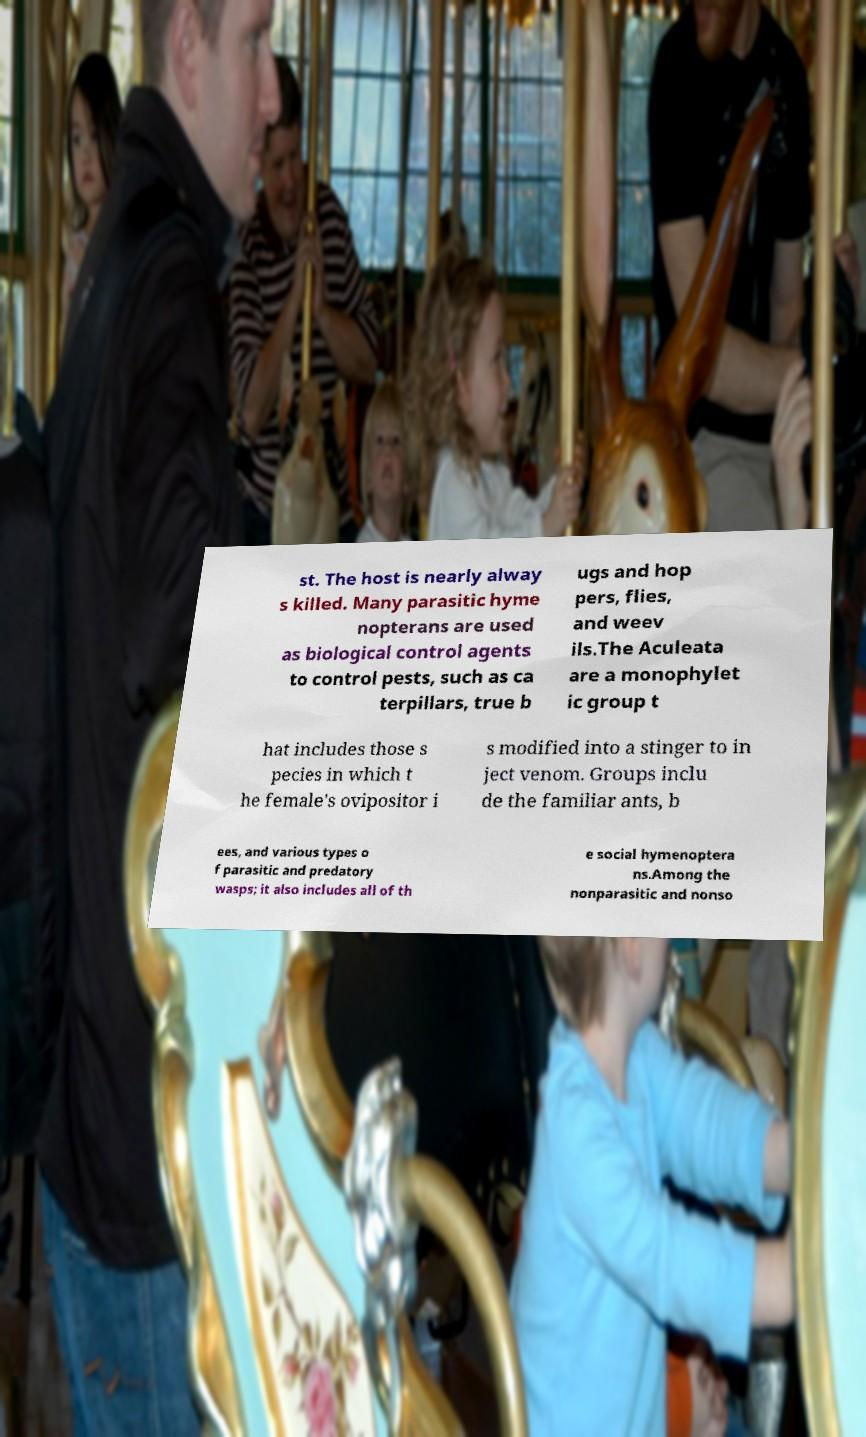I need the written content from this picture converted into text. Can you do that? st. The host is nearly alway s killed. Many parasitic hyme nopterans are used as biological control agents to control pests, such as ca terpillars, true b ugs and hop pers, flies, and weev ils.The Aculeata are a monophylet ic group t hat includes those s pecies in which t he female's ovipositor i s modified into a stinger to in ject venom. Groups inclu de the familiar ants, b ees, and various types o f parasitic and predatory wasps; it also includes all of th e social hymenoptera ns.Among the nonparasitic and nonso 